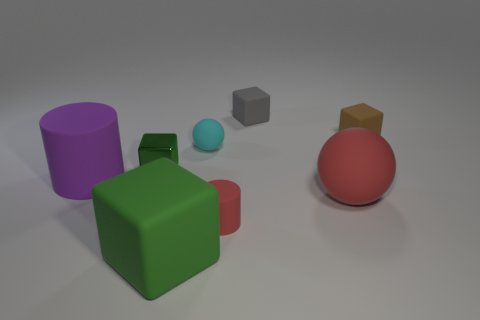Add 2 big rubber cylinders. How many objects exist? 10 Subtract all blue blocks. Subtract all red spheres. How many blocks are left? 4 Subtract all cylinders. How many objects are left? 6 Subtract 2 green blocks. How many objects are left? 6 Subtract all large objects. Subtract all gray matte cubes. How many objects are left? 4 Add 4 big green things. How many big green things are left? 5 Add 5 red things. How many red things exist? 7 